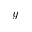Convert formula to latex. <formula><loc_0><loc_0><loc_500><loc_500>y</formula> 